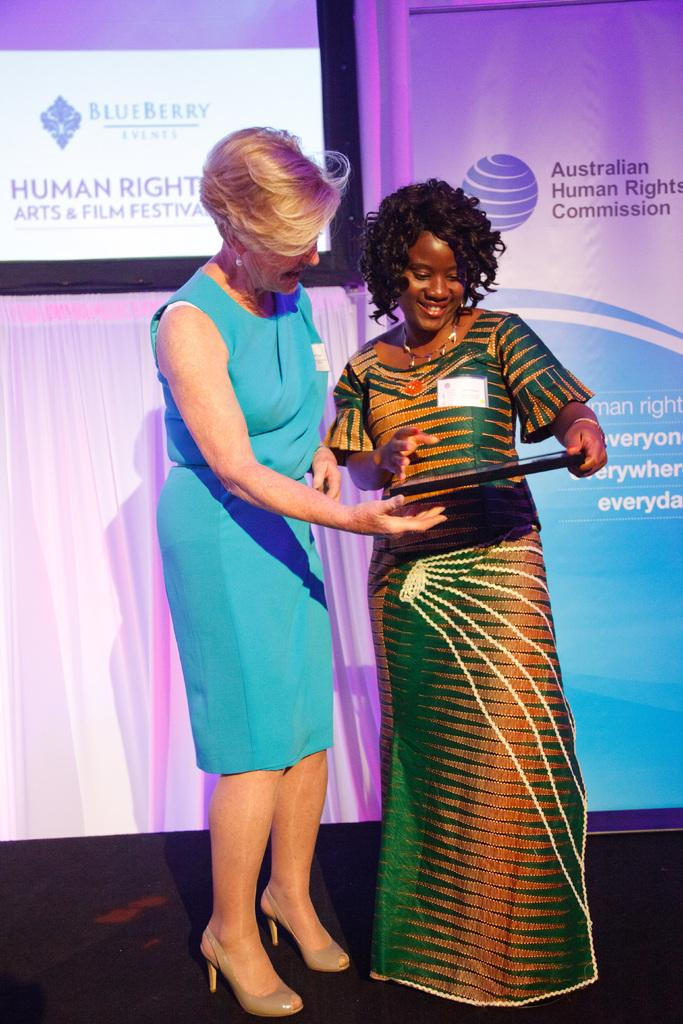How many people are in the image? There are two girls in the image. Where are the girls located in the image? The girls are standing on a stage. What is one of the girls doing in the image? One of the girls is holding an object. What can be seen in the background of the image? There is a screen and a banner in the background of the image. How long does it take for the girls to swim across the stage in the image? There is no swimming activity depicted in the image, as the girls are standing on a stage. 